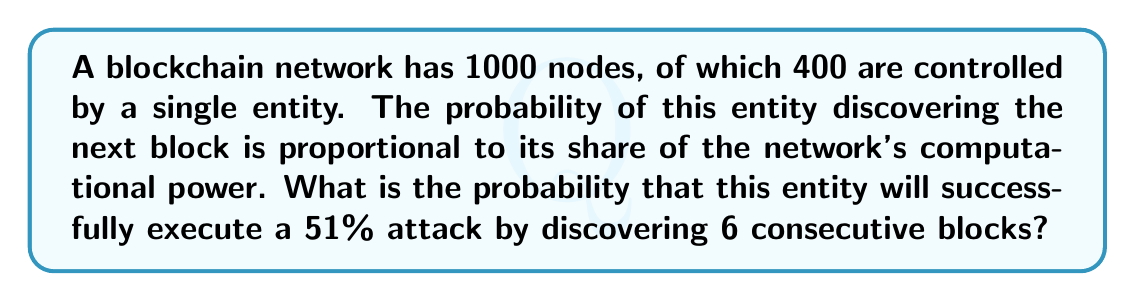Could you help me with this problem? To solve this problem, we need to follow these steps:

1) First, let's calculate the probability of the entity discovering a single block:
   $p = \frac{400}{1000} = 0.4$ or 40%

2) For a successful 51% attack, the entity needs to discover 6 consecutive blocks. This can be modeled as a series of independent events, each with probability $p$.

3) The probability of all these events occurring in sequence is given by multiplying the individual probabilities:

   $P(\text{6 consecutive blocks}) = p^6$

4) Substituting our value for $p$:

   $P(\text{6 consecutive blocks}) = (0.4)^6$

5) Calculate this value:

   $P(\text{6 consecutive blocks}) = (0.4)^6 = 0.004096$

6) Convert to a percentage:

   $0.004096 \times 100\% = 0.4096\%$

This means there's approximately a 0.4096% chance of the entity successfully executing a 51% attack by discovering 6 consecutive blocks.
Answer: $0.4096\%$ 